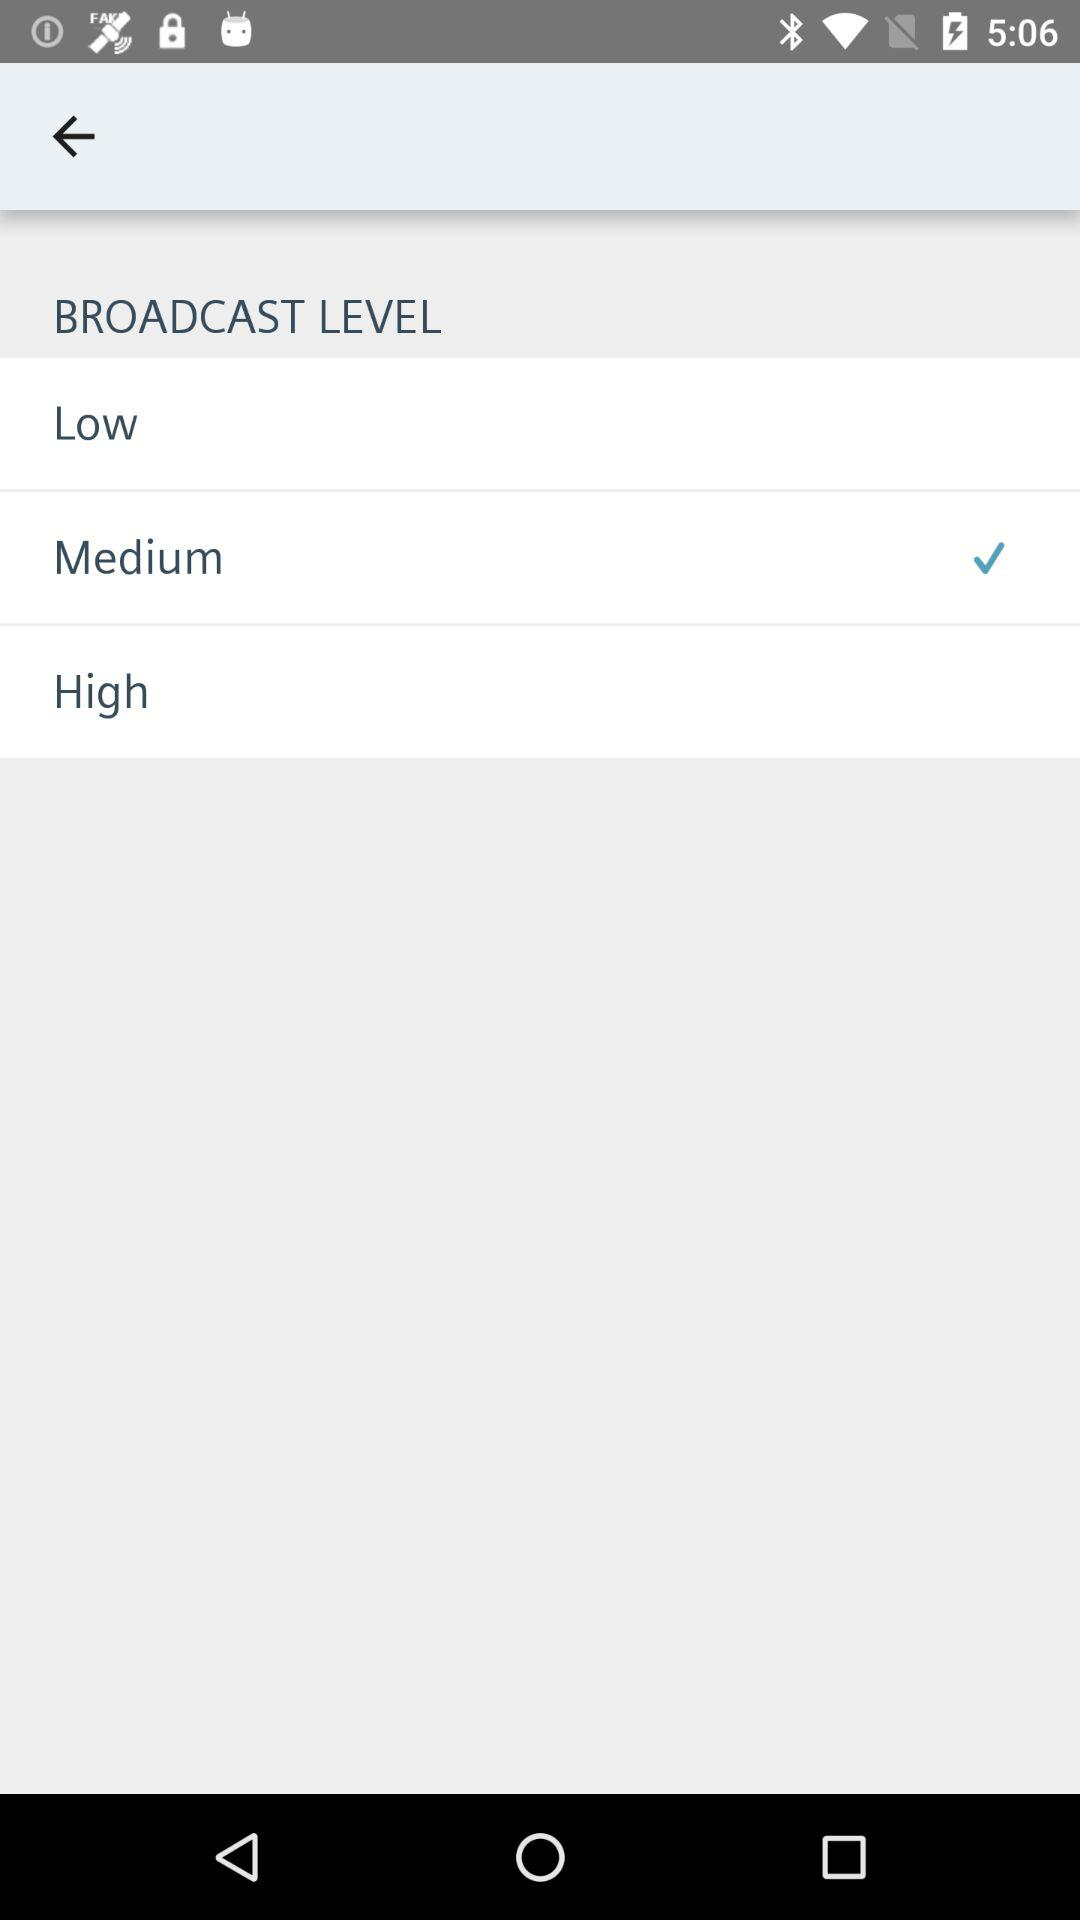How many levels are there?
Answer the question using a single word or phrase. 3 